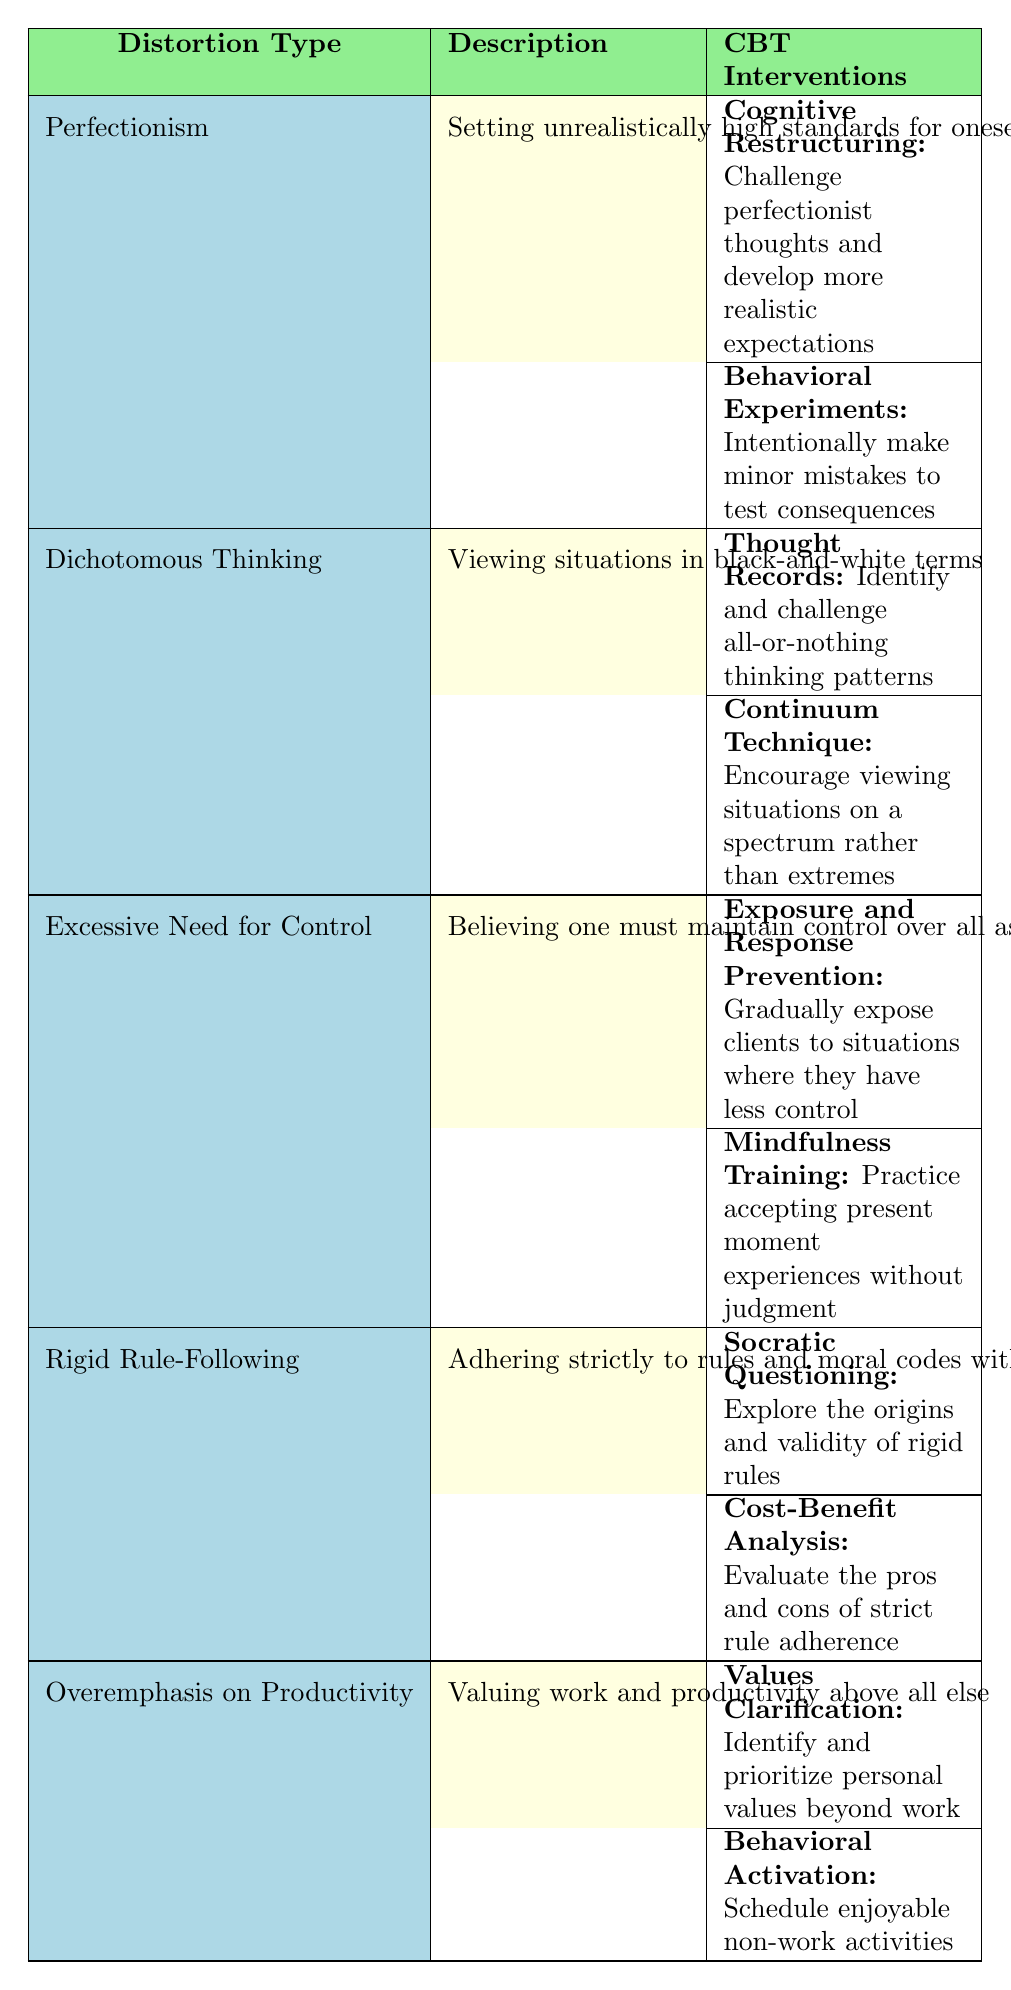What type of cognitive distortion is associated with setting unrealistically high standards? The table lists "Perfectionism" as the distortion type associated with setting unrealistically high standards for oneself and others.
Answer: Perfectionism Which CBT intervention involves challenging perfectionist thoughts? The intervention "Cognitive Restructuring" is mentioned in the table as a technique to challenge perfectionist thoughts and develop more realistic expectations.
Answer: Cognitive Restructuring Is "Dichotomous Thinking" associated with any CBT interventions? Yes, the table indicates that "Dichotomous Thinking" has two associated CBT interventions: "Thought Records" and "Continuum Technique."
Answer: Yes How many CBT interventions are listed for "Excessive Need for Control"? There are two CBT interventions listed for "Excessive Need for Control": "Exposure and Response Prevention" and "Mindfulness Training."
Answer: 2 Which cognitive distortion has the description "Viewing situations in black-and-white terms"? The distortion with that description is "Dichotomous Thinking," as specified in the table.
Answer: Dichotomous Thinking What is the technique used to explore the origins of rigid rules? The technique used for that purpose is "Socratic Questioning," which is identified in the table under "Rigid Rule-Following."
Answer: Socratic Questioning If a client struggles with excessive need for control, which technique could help them accept present moment experiences? The technique that could help with that is "Mindfulness Training," listed in the table for "Excessive Need for Control."
Answer: Mindfulness Training What is the common theme among the CBT interventions for "Overemphasis on Productivity"? The common theme among the interventions is to identify personal values beyond work and to engage in enjoyable non-work activities.
Answer: Identifying values and scheduling enjoyable activities List all the CBT techniques associated with "Perfectionism." The CBT techniques for "Perfectionism" are "Cognitive Restructuring" and "Behavioral Experiments," as found in the table.
Answer: Cognitive Restructuring, Behavioral Experiments Which distortion type involves evaluating the pros and cons of strict rule adherence? "Rigid Rule-Following" involves evaluating the pros and cons of strict rule adherence, as stated in the table.
Answer: Rigid Rule-Following What cognitive distortion is addressed by using the "Continuum Technique"? The cognitive distortion addressed is "Dichotomous Thinking," according to the information in the table.
Answer: Dichotomous Thinking Which two CBT techniques are used to combat the distortion of Perfectionism? The techniques are "Cognitive Restructuring" and "Behavioral Experiments," both listed under "Perfectionism" in the table.
Answer: Cognitive Restructuring, Behavioral Experiments Compare the number of interventions associated with "Rigid Rule-Following" and "Overemphasis on Productivity." Both "Rigid Rule-Following" and "Overemphasis on Productivity" are associated with two interventions each, making the counts equal.
Answer: Both have 2 interventions Identify a technique that helps individuals prioritize personal values beyond work. The technique is "Values Clarification," which is mentioned under "Overemphasis on Productivity."
Answer: Values Clarification Does "Exposure and Response Prevention" relate to reducing the need for control? Yes, "Exposure and Response Prevention" is specifically listed as a technique under "Excessive Need for Control."
Answer: Yes 